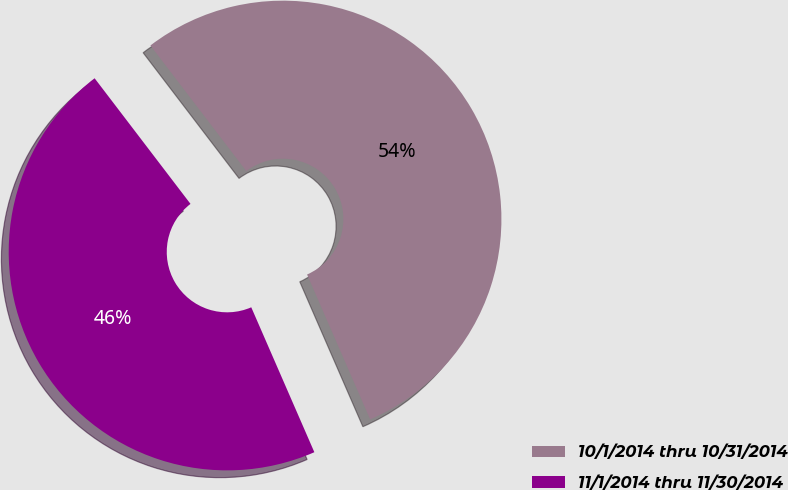Convert chart to OTSL. <chart><loc_0><loc_0><loc_500><loc_500><pie_chart><fcel>10/1/2014 thru 10/31/2014<fcel>11/1/2014 thru 11/30/2014<nl><fcel>53.84%<fcel>46.16%<nl></chart> 